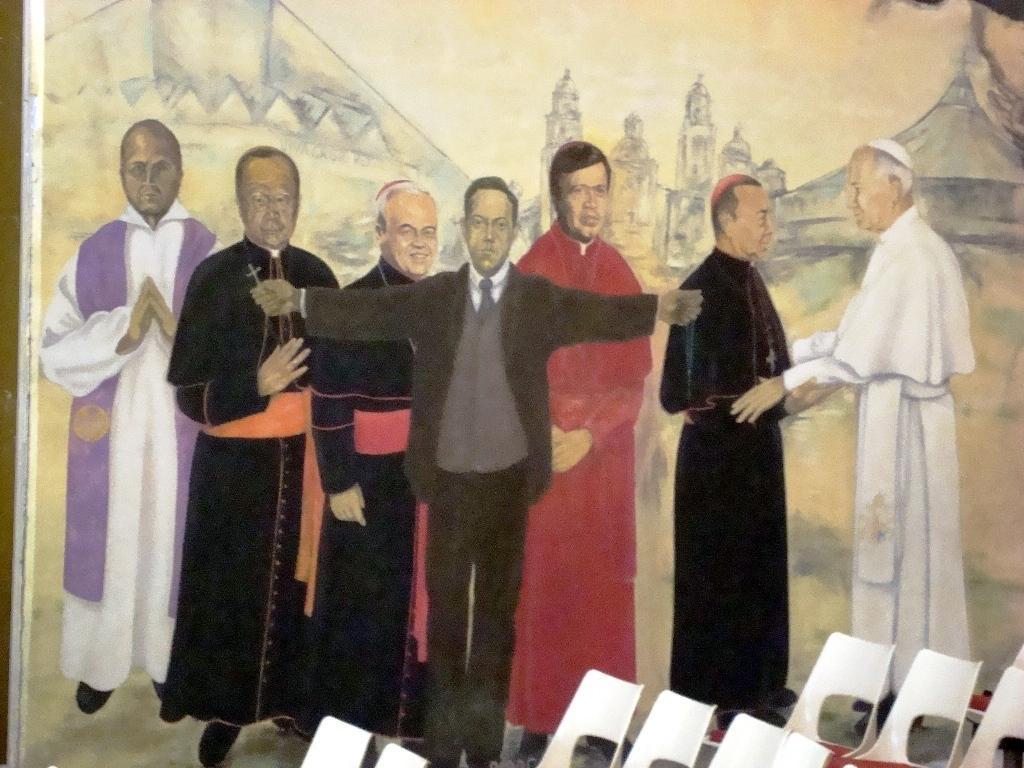How would you summarize this image in a sentence or two? This is a painted picture and in the foreground of this image, there are persons standing and showing different culture dresses. In the background, there are buildings and on bottom, there are few chairs. 